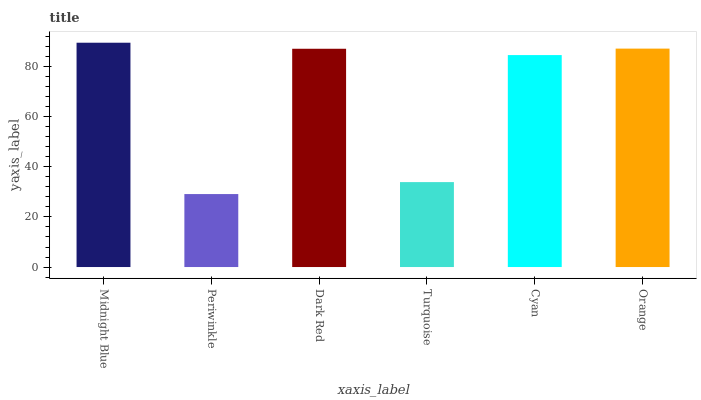Is Periwinkle the minimum?
Answer yes or no. Yes. Is Midnight Blue the maximum?
Answer yes or no. Yes. Is Dark Red the minimum?
Answer yes or no. No. Is Dark Red the maximum?
Answer yes or no. No. Is Dark Red greater than Periwinkle?
Answer yes or no. Yes. Is Periwinkle less than Dark Red?
Answer yes or no. Yes. Is Periwinkle greater than Dark Red?
Answer yes or no. No. Is Dark Red less than Periwinkle?
Answer yes or no. No. Is Dark Red the high median?
Answer yes or no. Yes. Is Cyan the low median?
Answer yes or no. Yes. Is Cyan the high median?
Answer yes or no. No. Is Periwinkle the low median?
Answer yes or no. No. 